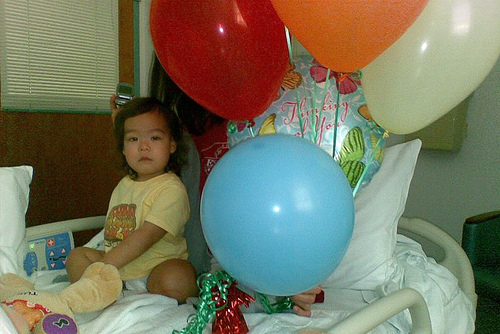<image>
Is there a balloon behind the balloon? Yes. From this viewpoint, the balloon is positioned behind the balloon, with the balloon partially or fully occluding the balloon. Is the balloon on the bed? Yes. Looking at the image, I can see the balloon is positioned on top of the bed, with the bed providing support. 